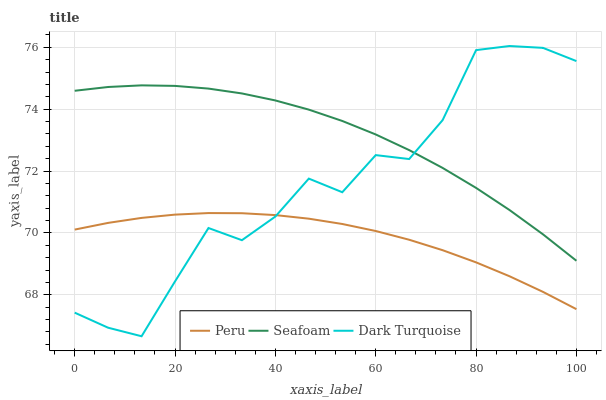Does Peru have the minimum area under the curve?
Answer yes or no. Yes. Does Seafoam have the maximum area under the curve?
Answer yes or no. Yes. Does Seafoam have the minimum area under the curve?
Answer yes or no. No. Does Peru have the maximum area under the curve?
Answer yes or no. No. Is Peru the smoothest?
Answer yes or no. Yes. Is Dark Turquoise the roughest?
Answer yes or no. Yes. Is Seafoam the smoothest?
Answer yes or no. No. Is Seafoam the roughest?
Answer yes or no. No. Does Dark Turquoise have the lowest value?
Answer yes or no. Yes. Does Peru have the lowest value?
Answer yes or no. No. Does Dark Turquoise have the highest value?
Answer yes or no. Yes. Does Seafoam have the highest value?
Answer yes or no. No. Is Peru less than Seafoam?
Answer yes or no. Yes. Is Seafoam greater than Peru?
Answer yes or no. Yes. Does Dark Turquoise intersect Seafoam?
Answer yes or no. Yes. Is Dark Turquoise less than Seafoam?
Answer yes or no. No. Is Dark Turquoise greater than Seafoam?
Answer yes or no. No. Does Peru intersect Seafoam?
Answer yes or no. No. 